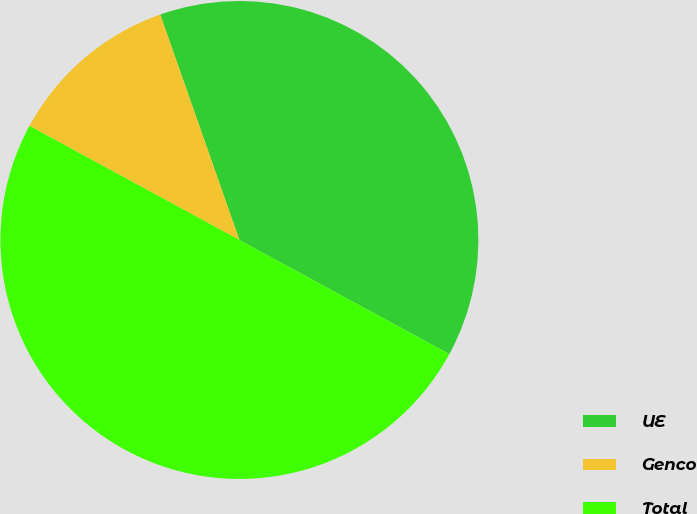Convert chart. <chart><loc_0><loc_0><loc_500><loc_500><pie_chart><fcel>UE<fcel>Genco<fcel>Total<nl><fcel>38.3%<fcel>11.7%<fcel>50.0%<nl></chart> 